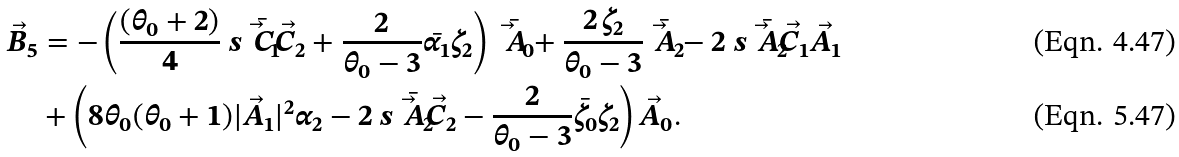Convert formula to latex. <formula><loc_0><loc_0><loc_500><loc_500>\vec { B } _ { 5 } & = - \left ( \frac { ( \theta _ { 0 } + 2 ) } { 4 } \ s { \bar { \vec { C } _ { 1 } } } { \vec { C } _ { 2 } } + \frac { 2 } { \theta _ { 0 } - 3 } \bar { \alpha _ { 1 } } \zeta _ { 2 } \right ) \bar { \vec { A } _ { 0 } } + \frac { 2 \, \zeta _ { 2 } } { \theta _ { 0 } - 3 } \bar { \vec { A } _ { 2 } } - 2 \ s { \bar { \vec { A } _ { 2 } } } { \vec { C } _ { 1 } } \vec { A } _ { 1 } \\ & + \left ( 8 \theta _ { 0 } ( \theta _ { 0 } + 1 ) | \vec { A } _ { 1 } | ^ { 2 } \alpha _ { 2 } - 2 \ s { \bar { \vec { A } _ { 2 } } } { \vec { C } _ { 2 } } - \frac { 2 } { \theta _ { 0 } - 3 } \bar { \zeta _ { 0 } } \zeta _ { 2 } \right ) \vec { A } _ { 0 } .</formula> 